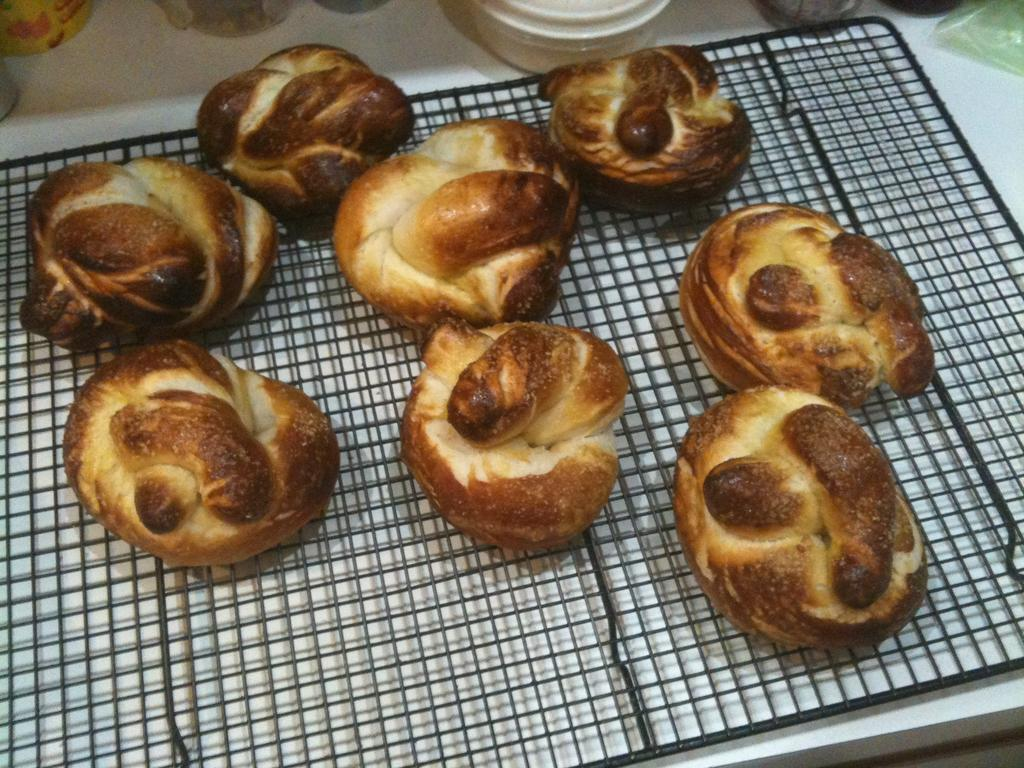What type of objects are holding the food items in the image? There are food items on a metallic object in the image. Can you describe the objects that are on the top side of the picture? Unfortunately, the provided facts do not give enough information to describe the objects on the top side of the picture. How does the elbow contribute to the hearing process in the image? There is no mention of an elbow or hearing process in the image, so it is not possible to answer that question. 